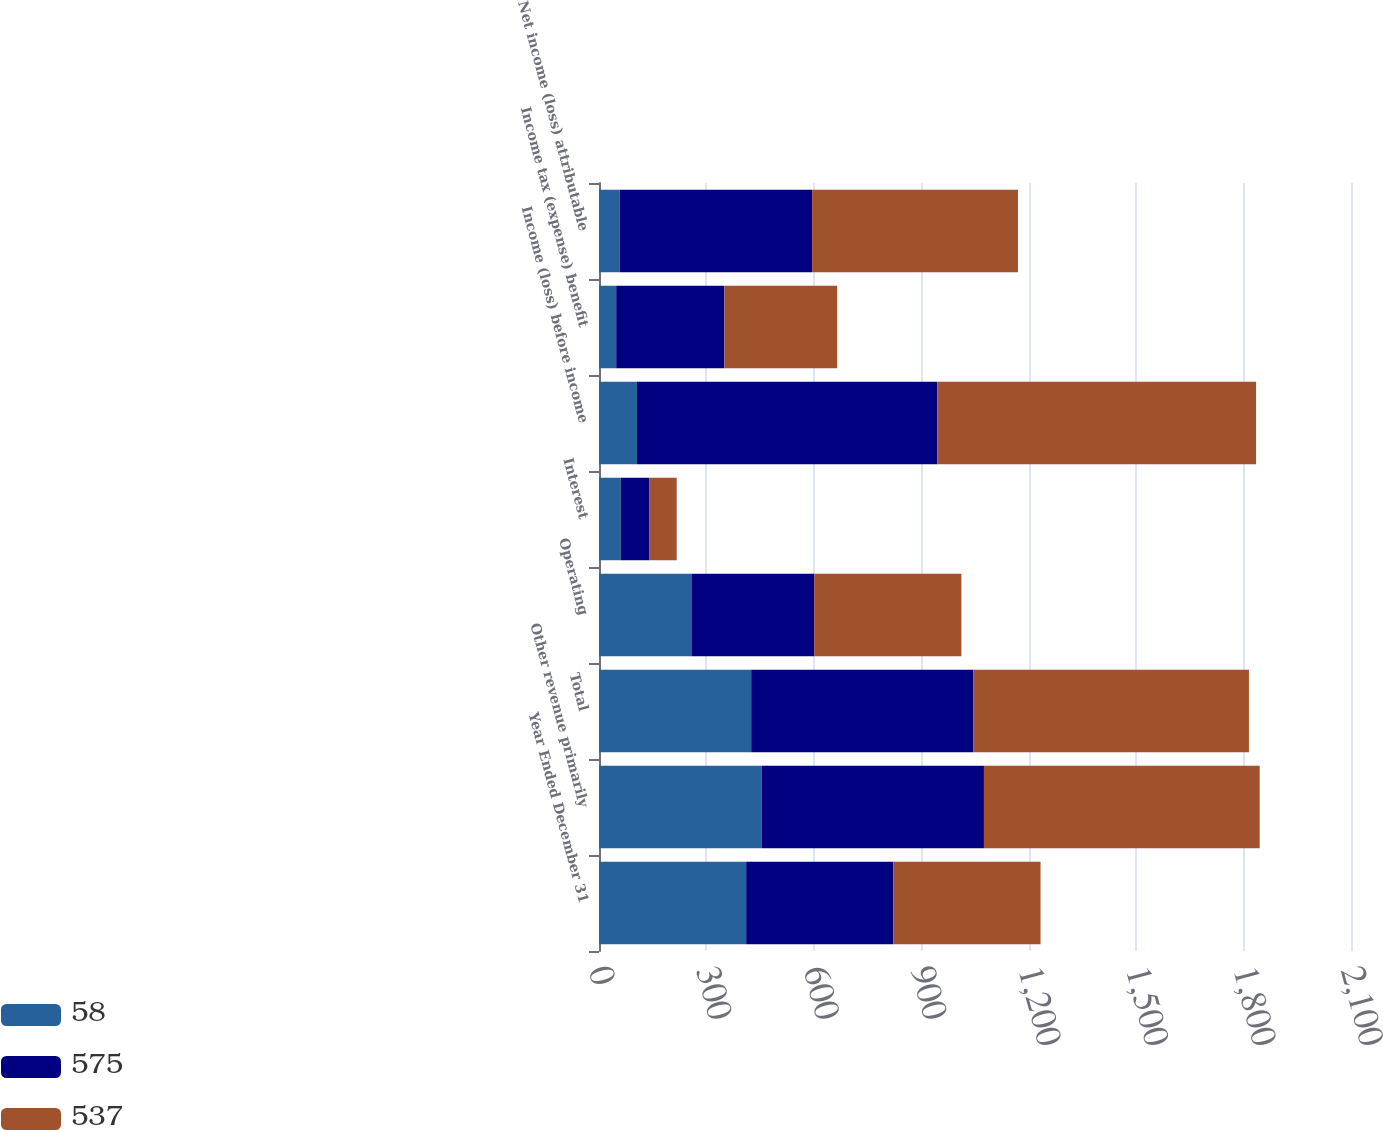Convert chart to OTSL. <chart><loc_0><loc_0><loc_500><loc_500><stacked_bar_chart><ecel><fcel>Year Ended December 31<fcel>Other revenue primarily<fcel>Total<fcel>Operating<fcel>Interest<fcel>Income (loss) before income<fcel>Income tax (expense) benefit<fcel>Net income (loss) attributable<nl><fcel>58<fcel>411<fcel>455<fcel>425<fcel>258<fcel>61<fcel>106<fcel>48<fcel>58<nl><fcel>575<fcel>411<fcel>620<fcel>620<fcel>343<fcel>80<fcel>839<fcel>302<fcel>537<nl><fcel>537<fcel>411<fcel>770<fcel>770<fcel>411<fcel>76<fcel>890<fcel>315<fcel>575<nl></chart> 